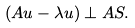<formula> <loc_0><loc_0><loc_500><loc_500>( A u - \lambda u ) \perp A S .</formula> 